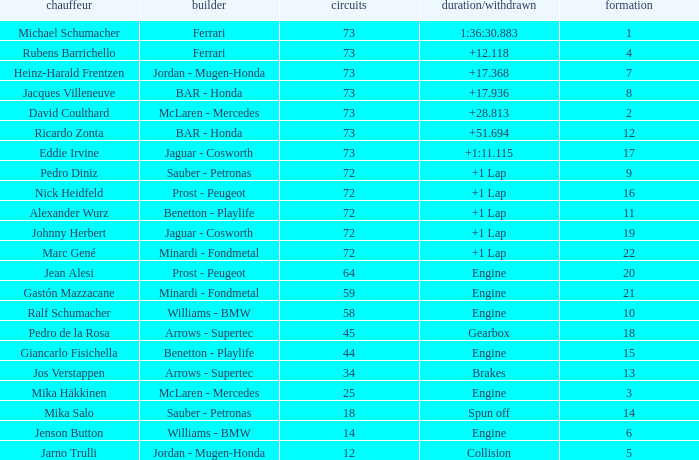How many laps did Giancarlo Fisichella do with a grid larger than 15? 0.0. 